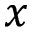Convert formula to latex. <formula><loc_0><loc_0><loc_500><loc_500>x</formula> 